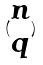Convert formula to latex. <formula><loc_0><loc_0><loc_500><loc_500>( \begin{matrix} n \\ q \end{matrix} )</formula> 